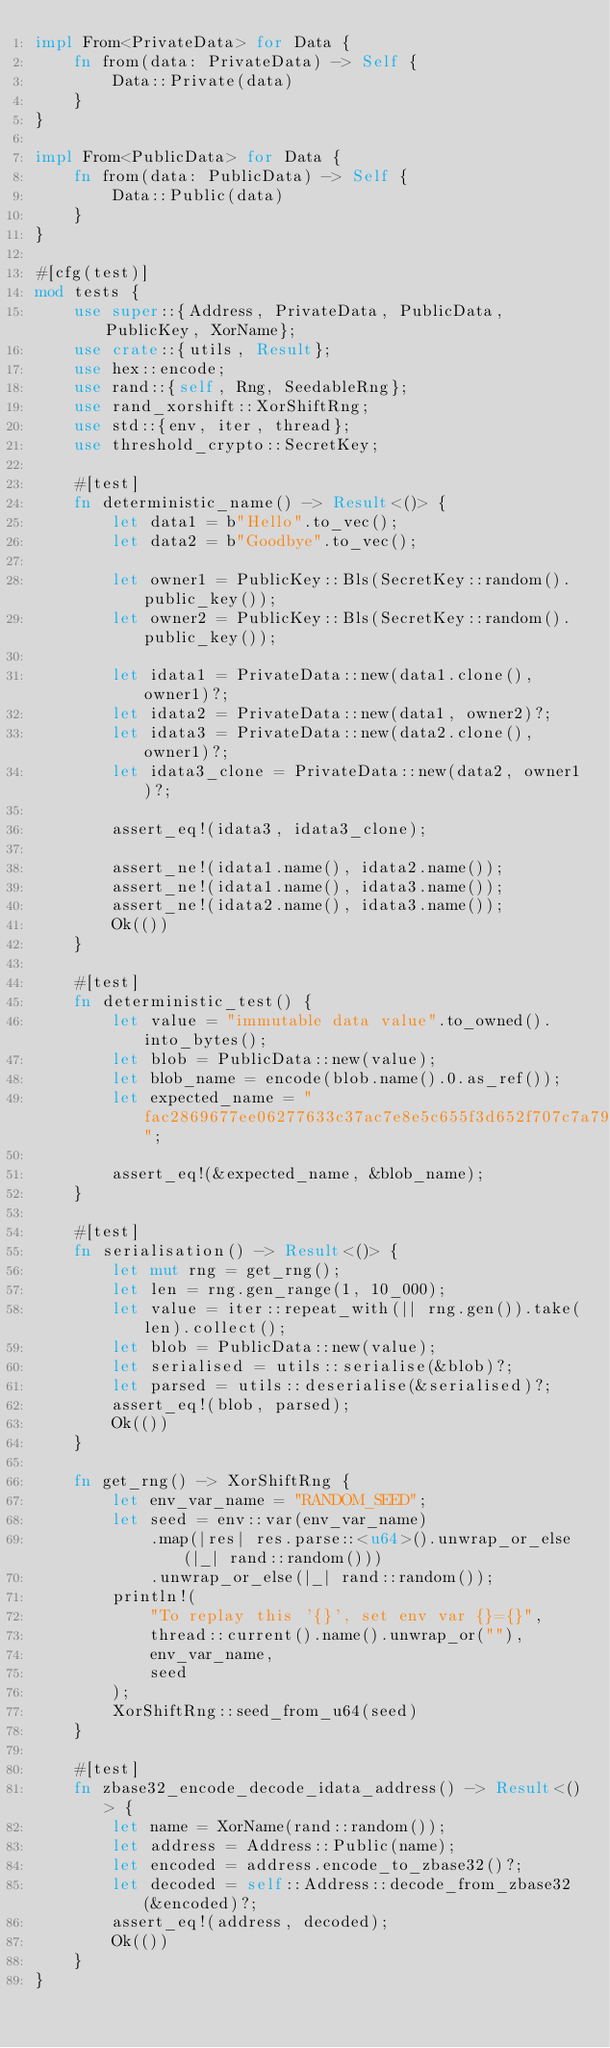Convert code to text. <code><loc_0><loc_0><loc_500><loc_500><_Rust_>impl From<PrivateData> for Data {
    fn from(data: PrivateData) -> Self {
        Data::Private(data)
    }
}

impl From<PublicData> for Data {
    fn from(data: PublicData) -> Self {
        Data::Public(data)
    }
}

#[cfg(test)]
mod tests {
    use super::{Address, PrivateData, PublicData, PublicKey, XorName};
    use crate::{utils, Result};
    use hex::encode;
    use rand::{self, Rng, SeedableRng};
    use rand_xorshift::XorShiftRng;
    use std::{env, iter, thread};
    use threshold_crypto::SecretKey;

    #[test]
    fn deterministic_name() -> Result<()> {
        let data1 = b"Hello".to_vec();
        let data2 = b"Goodbye".to_vec();

        let owner1 = PublicKey::Bls(SecretKey::random().public_key());
        let owner2 = PublicKey::Bls(SecretKey::random().public_key());

        let idata1 = PrivateData::new(data1.clone(), owner1)?;
        let idata2 = PrivateData::new(data1, owner2)?;
        let idata3 = PrivateData::new(data2.clone(), owner1)?;
        let idata3_clone = PrivateData::new(data2, owner1)?;

        assert_eq!(idata3, idata3_clone);

        assert_ne!(idata1.name(), idata2.name());
        assert_ne!(idata1.name(), idata3.name());
        assert_ne!(idata2.name(), idata3.name());
        Ok(())
    }

    #[test]
    fn deterministic_test() {
        let value = "immutable data value".to_owned().into_bytes();
        let blob = PublicData::new(value);
        let blob_name = encode(blob.name().0.as_ref());
        let expected_name = "fac2869677ee06277633c37ac7e8e5c655f3d652f707c7a79fab930d584a3016";

        assert_eq!(&expected_name, &blob_name);
    }

    #[test]
    fn serialisation() -> Result<()> {
        let mut rng = get_rng();
        let len = rng.gen_range(1, 10_000);
        let value = iter::repeat_with(|| rng.gen()).take(len).collect();
        let blob = PublicData::new(value);
        let serialised = utils::serialise(&blob)?;
        let parsed = utils::deserialise(&serialised)?;
        assert_eq!(blob, parsed);
        Ok(())
    }

    fn get_rng() -> XorShiftRng {
        let env_var_name = "RANDOM_SEED";
        let seed = env::var(env_var_name)
            .map(|res| res.parse::<u64>().unwrap_or_else(|_| rand::random()))
            .unwrap_or_else(|_| rand::random());
        println!(
            "To replay this '{}', set env var {}={}",
            thread::current().name().unwrap_or(""),
            env_var_name,
            seed
        );
        XorShiftRng::seed_from_u64(seed)
    }

    #[test]
    fn zbase32_encode_decode_idata_address() -> Result<()> {
        let name = XorName(rand::random());
        let address = Address::Public(name);
        let encoded = address.encode_to_zbase32()?;
        let decoded = self::Address::decode_from_zbase32(&encoded)?;
        assert_eq!(address, decoded);
        Ok(())
    }
}
</code> 